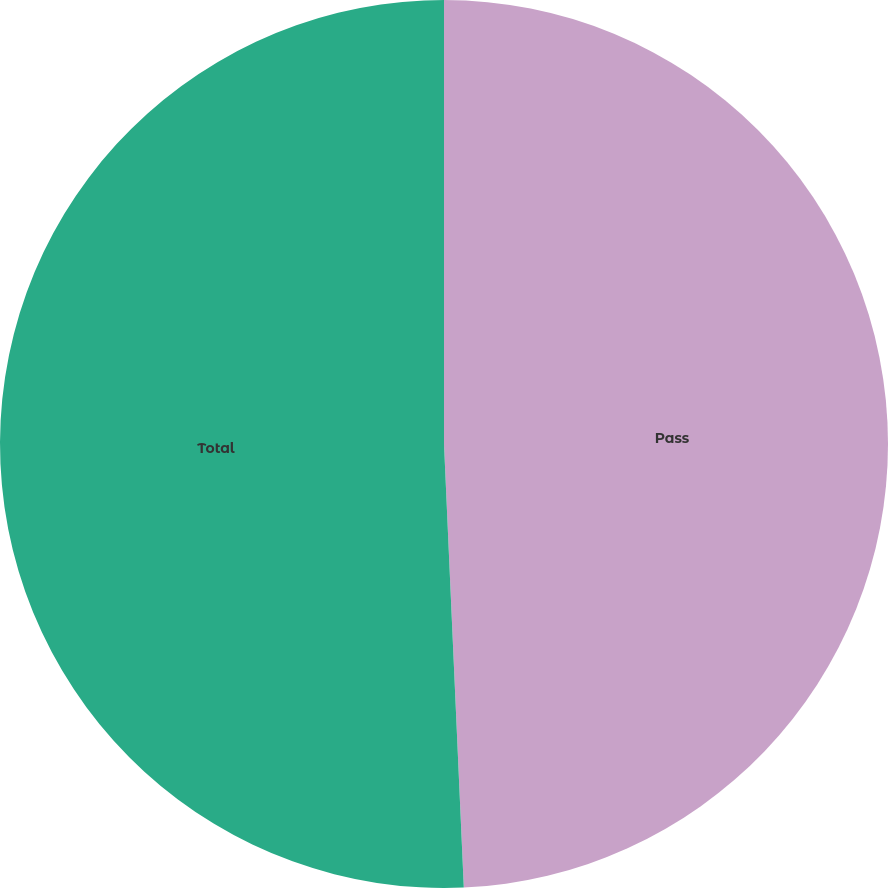Convert chart. <chart><loc_0><loc_0><loc_500><loc_500><pie_chart><fcel>Pass<fcel>Total<nl><fcel>49.29%<fcel>50.71%<nl></chart> 